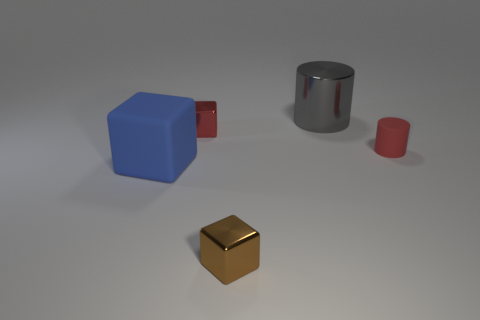What is the material of the cube that is to the left of the cube behind the big block?
Your response must be concise. Rubber. Are there more small red rubber cylinders right of the matte cylinder than small rubber things right of the brown object?
Your answer should be very brief. No. The shiny cylinder is what size?
Offer a very short reply. Large. There is a tiny shiny thing in front of the red cylinder; is it the same color as the rubber block?
Offer a terse response. No. Is there any other thing that has the same shape as the large gray thing?
Ensure brevity in your answer.  Yes. There is a large object behind the matte block; is there a large rubber cube to the right of it?
Offer a very short reply. No. Are there fewer large gray things in front of the small rubber cylinder than large blue cubes that are left of the big blue rubber block?
Offer a terse response. No. How big is the matte thing that is in front of the small red thing right of the tiny cube in front of the blue thing?
Your answer should be very brief. Large. There is a red thing to the right of the brown block; is its size the same as the blue object?
Offer a very short reply. No. What number of other objects are the same material as the gray cylinder?
Offer a terse response. 2. 